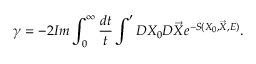<formula> <loc_0><loc_0><loc_500><loc_500>\gamma = - 2 I m \int _ { 0 } ^ { \infty } \frac { d t } { t } \int ^ { \prime } D X _ { 0 } D \vec { X } e ^ { - S ( X _ { 0 } , \vec { X } , E ) } .</formula> 